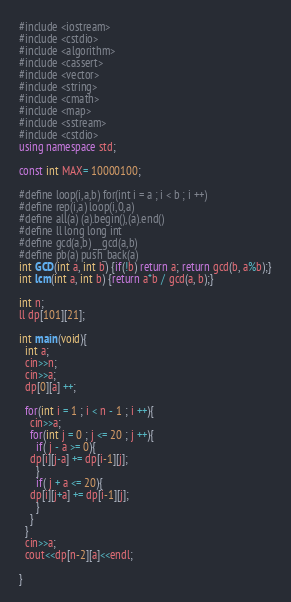<code> <loc_0><loc_0><loc_500><loc_500><_C++_>#include <iostream>
#include <cstdio>
#include <algorithm>
#include <cassert>
#include <vector>
#include <string>
#include <cmath>
#include <map> 
#include <sstream>
#include <cstdio>
using namespace std;
 
const int MAX= 10000100;

#define loop(i,a,b) for(int i = a ; i < b ; i ++)
#define rep(i,a) loop(i,0,a)
#define all(a) (a).begin(),(a).end()
#define ll long long int
#define gcd(a,b) __gcd(a,b)
#define pb(a) push_back(a)
int GCD(int a, int b) {if(!b) return a; return gcd(b, a%b);}
int lcm(int a, int b) {return a*b / gcd(a, b);}

int n;
ll dp[101][21];

int main(void){
  int a;
  cin>>n;
  cin>>a;
  dp[0][a] ++;

  for(int i = 1 ; i < n - 1 ; i ++){
    cin>>a;
    for(int j = 0 ; j <= 20 ; j ++){
      if( j - a >= 0){
	dp[i][j-a] += dp[i-1][j];
      }
      if( j + a <= 20){
	dp[i][j+a] += dp[i-1][j];
      }
    }
  }
  cin>>a;
  cout<<dp[n-2][a]<<endl;

}</code> 